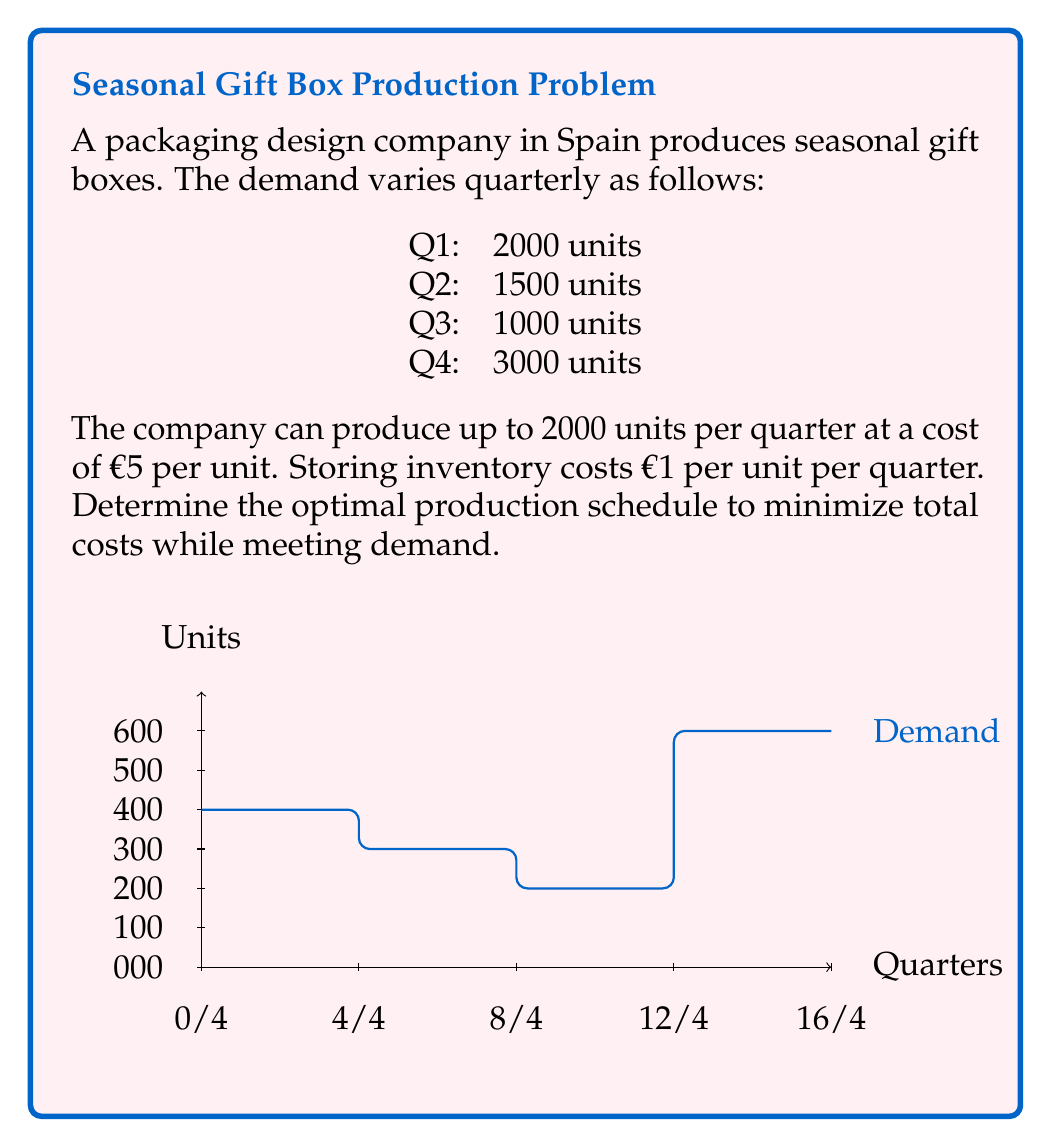Help me with this question. Let's solve this problem step-by-step using the least cost approach:

1) First, let's calculate the cumulative demand:
   Q1: 2000
   Q2: 2000 + 1500 = 3500
   Q3: 3500 + 1000 = 4500
   Q4: 4500 + 3000 = 7500

2) Now, let's determine the production for each quarter:

   Q1: Produce 2000 (matches demand, no inventory)
   Cost: $2000 \times €5 = €10000$

   Q2: Produce 1500 (matches demand, no inventory)
   Cost: $1500 \times €5 = €7500$

   Q3: Produce 1000 (matches demand, no inventory)
   Cost: $1000 \times €5 = €5000$

   Q4: The demand is 3000, but we can only produce 2000.
   Produce 2000 in Q4: $2000 \times €5 = €10000$
   We need to produce 1000 in Q3 and store it:
   Production cost: $1000 \times €5 = €5000$
   Storage cost: $1000 \times €1 = €1000$

3) Total cost calculation:
   $€10000 + €7500 + €5000 + €10000 + €5000 + €1000 = €38500$

This schedule ensures all demand is met at the minimum cost.
Answer: Q1: 2000, Q2: 1500, Q3: 2000, Q4: 2000; Total cost: €38500 